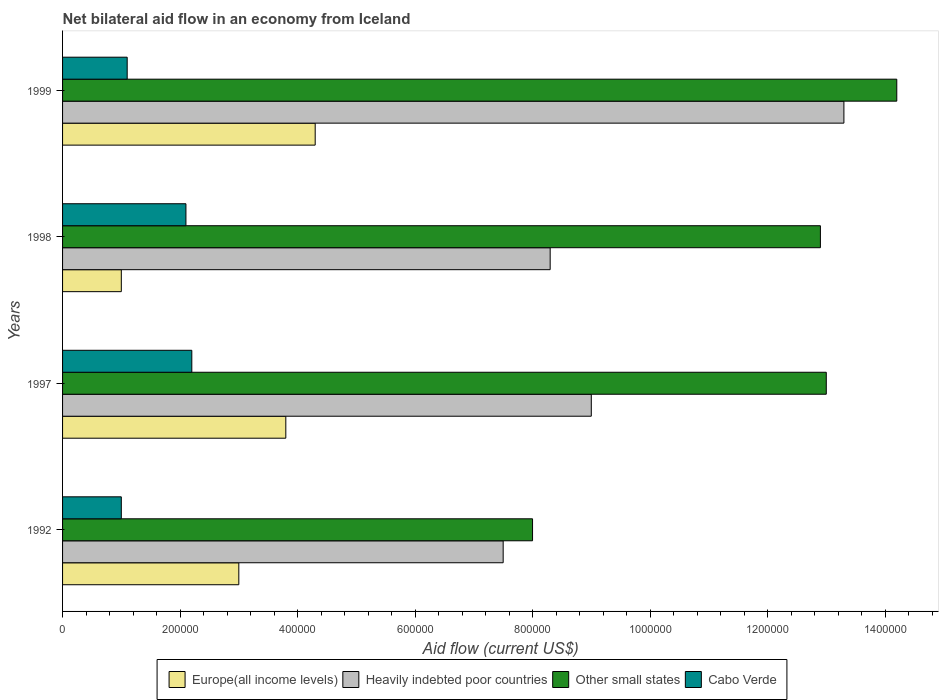How many different coloured bars are there?
Provide a succinct answer. 4. How many groups of bars are there?
Ensure brevity in your answer.  4. Are the number of bars per tick equal to the number of legend labels?
Ensure brevity in your answer.  Yes. Are the number of bars on each tick of the Y-axis equal?
Offer a terse response. Yes. How many bars are there on the 4th tick from the top?
Your response must be concise. 4. What is the net bilateral aid flow in Heavily indebted poor countries in 1999?
Give a very brief answer. 1.33e+06. Across all years, what is the maximum net bilateral aid flow in Heavily indebted poor countries?
Make the answer very short. 1.33e+06. Across all years, what is the minimum net bilateral aid flow in Other small states?
Ensure brevity in your answer.  8.00e+05. What is the total net bilateral aid flow in Europe(all income levels) in the graph?
Give a very brief answer. 1.21e+06. What is the difference between the net bilateral aid flow in Europe(all income levels) in 1997 and the net bilateral aid flow in Cabo Verde in 1999?
Your response must be concise. 2.70e+05. What is the average net bilateral aid flow in Europe(all income levels) per year?
Your answer should be compact. 3.02e+05. In the year 1997, what is the difference between the net bilateral aid flow in Cabo Verde and net bilateral aid flow in Other small states?
Your answer should be very brief. -1.08e+06. What is the ratio of the net bilateral aid flow in Other small states in 1992 to that in 1997?
Keep it short and to the point. 0.62. Is the net bilateral aid flow in Cabo Verde in 1992 less than that in 1999?
Provide a short and direct response. Yes. Is the difference between the net bilateral aid flow in Cabo Verde in 1997 and 1998 greater than the difference between the net bilateral aid flow in Other small states in 1997 and 1998?
Your response must be concise. No. What is the difference between the highest and the second highest net bilateral aid flow in Europe(all income levels)?
Provide a succinct answer. 5.00e+04. What is the difference between the highest and the lowest net bilateral aid flow in Heavily indebted poor countries?
Keep it short and to the point. 5.80e+05. In how many years, is the net bilateral aid flow in Other small states greater than the average net bilateral aid flow in Other small states taken over all years?
Ensure brevity in your answer.  3. Is it the case that in every year, the sum of the net bilateral aid flow in Heavily indebted poor countries and net bilateral aid flow in Cabo Verde is greater than the sum of net bilateral aid flow in Other small states and net bilateral aid flow in Europe(all income levels)?
Your answer should be compact. No. What does the 2nd bar from the top in 1998 represents?
Keep it short and to the point. Other small states. What does the 2nd bar from the bottom in 1998 represents?
Offer a terse response. Heavily indebted poor countries. Is it the case that in every year, the sum of the net bilateral aid flow in Europe(all income levels) and net bilateral aid flow in Cabo Verde is greater than the net bilateral aid flow in Other small states?
Make the answer very short. No. Are all the bars in the graph horizontal?
Your answer should be very brief. Yes. What is the difference between two consecutive major ticks on the X-axis?
Make the answer very short. 2.00e+05. Are the values on the major ticks of X-axis written in scientific E-notation?
Give a very brief answer. No. Does the graph contain any zero values?
Your answer should be very brief. No. How are the legend labels stacked?
Make the answer very short. Horizontal. What is the title of the graph?
Offer a terse response. Net bilateral aid flow in an economy from Iceland. What is the label or title of the X-axis?
Your response must be concise. Aid flow (current US$). What is the Aid flow (current US$) in Europe(all income levels) in 1992?
Offer a very short reply. 3.00e+05. What is the Aid flow (current US$) of Heavily indebted poor countries in 1992?
Your response must be concise. 7.50e+05. What is the Aid flow (current US$) of Cabo Verde in 1992?
Your response must be concise. 1.00e+05. What is the Aid flow (current US$) in Heavily indebted poor countries in 1997?
Keep it short and to the point. 9.00e+05. What is the Aid flow (current US$) in Other small states in 1997?
Offer a very short reply. 1.30e+06. What is the Aid flow (current US$) of Heavily indebted poor countries in 1998?
Make the answer very short. 8.30e+05. What is the Aid flow (current US$) in Other small states in 1998?
Keep it short and to the point. 1.29e+06. What is the Aid flow (current US$) of Heavily indebted poor countries in 1999?
Give a very brief answer. 1.33e+06. What is the Aid flow (current US$) in Other small states in 1999?
Provide a succinct answer. 1.42e+06. What is the Aid flow (current US$) in Cabo Verde in 1999?
Provide a short and direct response. 1.10e+05. Across all years, what is the maximum Aid flow (current US$) in Heavily indebted poor countries?
Provide a succinct answer. 1.33e+06. Across all years, what is the maximum Aid flow (current US$) of Other small states?
Keep it short and to the point. 1.42e+06. Across all years, what is the maximum Aid flow (current US$) in Cabo Verde?
Your answer should be very brief. 2.20e+05. Across all years, what is the minimum Aid flow (current US$) of Heavily indebted poor countries?
Offer a terse response. 7.50e+05. Across all years, what is the minimum Aid flow (current US$) in Cabo Verde?
Your answer should be very brief. 1.00e+05. What is the total Aid flow (current US$) in Europe(all income levels) in the graph?
Your answer should be compact. 1.21e+06. What is the total Aid flow (current US$) in Heavily indebted poor countries in the graph?
Provide a short and direct response. 3.81e+06. What is the total Aid flow (current US$) of Other small states in the graph?
Provide a short and direct response. 4.81e+06. What is the total Aid flow (current US$) in Cabo Verde in the graph?
Give a very brief answer. 6.40e+05. What is the difference between the Aid flow (current US$) in Europe(all income levels) in 1992 and that in 1997?
Provide a succinct answer. -8.00e+04. What is the difference between the Aid flow (current US$) in Heavily indebted poor countries in 1992 and that in 1997?
Offer a terse response. -1.50e+05. What is the difference between the Aid flow (current US$) in Other small states in 1992 and that in 1997?
Your answer should be compact. -5.00e+05. What is the difference between the Aid flow (current US$) of Cabo Verde in 1992 and that in 1997?
Ensure brevity in your answer.  -1.20e+05. What is the difference between the Aid flow (current US$) in Europe(all income levels) in 1992 and that in 1998?
Give a very brief answer. 2.00e+05. What is the difference between the Aid flow (current US$) in Heavily indebted poor countries in 1992 and that in 1998?
Your response must be concise. -8.00e+04. What is the difference between the Aid flow (current US$) in Other small states in 1992 and that in 1998?
Your response must be concise. -4.90e+05. What is the difference between the Aid flow (current US$) of Cabo Verde in 1992 and that in 1998?
Your answer should be compact. -1.10e+05. What is the difference between the Aid flow (current US$) of Heavily indebted poor countries in 1992 and that in 1999?
Keep it short and to the point. -5.80e+05. What is the difference between the Aid flow (current US$) in Other small states in 1992 and that in 1999?
Provide a succinct answer. -6.20e+05. What is the difference between the Aid flow (current US$) of Cabo Verde in 1992 and that in 1999?
Provide a short and direct response. -10000. What is the difference between the Aid flow (current US$) in Cabo Verde in 1997 and that in 1998?
Keep it short and to the point. 10000. What is the difference between the Aid flow (current US$) in Europe(all income levels) in 1997 and that in 1999?
Your answer should be very brief. -5.00e+04. What is the difference between the Aid flow (current US$) of Heavily indebted poor countries in 1997 and that in 1999?
Your answer should be compact. -4.30e+05. What is the difference between the Aid flow (current US$) in Other small states in 1997 and that in 1999?
Provide a short and direct response. -1.20e+05. What is the difference between the Aid flow (current US$) of Cabo Verde in 1997 and that in 1999?
Your answer should be compact. 1.10e+05. What is the difference between the Aid flow (current US$) of Europe(all income levels) in 1998 and that in 1999?
Ensure brevity in your answer.  -3.30e+05. What is the difference between the Aid flow (current US$) of Heavily indebted poor countries in 1998 and that in 1999?
Offer a very short reply. -5.00e+05. What is the difference between the Aid flow (current US$) in Other small states in 1998 and that in 1999?
Offer a very short reply. -1.30e+05. What is the difference between the Aid flow (current US$) in Cabo Verde in 1998 and that in 1999?
Make the answer very short. 1.00e+05. What is the difference between the Aid flow (current US$) in Europe(all income levels) in 1992 and the Aid flow (current US$) in Heavily indebted poor countries in 1997?
Your answer should be very brief. -6.00e+05. What is the difference between the Aid flow (current US$) in Heavily indebted poor countries in 1992 and the Aid flow (current US$) in Other small states in 1997?
Offer a very short reply. -5.50e+05. What is the difference between the Aid flow (current US$) of Heavily indebted poor countries in 1992 and the Aid flow (current US$) of Cabo Verde in 1997?
Provide a succinct answer. 5.30e+05. What is the difference between the Aid flow (current US$) of Other small states in 1992 and the Aid flow (current US$) of Cabo Verde in 1997?
Make the answer very short. 5.80e+05. What is the difference between the Aid flow (current US$) of Europe(all income levels) in 1992 and the Aid flow (current US$) of Heavily indebted poor countries in 1998?
Make the answer very short. -5.30e+05. What is the difference between the Aid flow (current US$) of Europe(all income levels) in 1992 and the Aid flow (current US$) of Other small states in 1998?
Make the answer very short. -9.90e+05. What is the difference between the Aid flow (current US$) of Heavily indebted poor countries in 1992 and the Aid flow (current US$) of Other small states in 1998?
Offer a very short reply. -5.40e+05. What is the difference between the Aid flow (current US$) of Heavily indebted poor countries in 1992 and the Aid flow (current US$) of Cabo Verde in 1998?
Your answer should be compact. 5.40e+05. What is the difference between the Aid flow (current US$) of Other small states in 1992 and the Aid flow (current US$) of Cabo Verde in 1998?
Offer a terse response. 5.90e+05. What is the difference between the Aid flow (current US$) of Europe(all income levels) in 1992 and the Aid flow (current US$) of Heavily indebted poor countries in 1999?
Offer a very short reply. -1.03e+06. What is the difference between the Aid flow (current US$) in Europe(all income levels) in 1992 and the Aid flow (current US$) in Other small states in 1999?
Your answer should be compact. -1.12e+06. What is the difference between the Aid flow (current US$) of Heavily indebted poor countries in 1992 and the Aid flow (current US$) of Other small states in 1999?
Offer a very short reply. -6.70e+05. What is the difference between the Aid flow (current US$) of Heavily indebted poor countries in 1992 and the Aid flow (current US$) of Cabo Verde in 1999?
Your answer should be compact. 6.40e+05. What is the difference between the Aid flow (current US$) of Other small states in 1992 and the Aid flow (current US$) of Cabo Verde in 1999?
Give a very brief answer. 6.90e+05. What is the difference between the Aid flow (current US$) in Europe(all income levels) in 1997 and the Aid flow (current US$) in Heavily indebted poor countries in 1998?
Make the answer very short. -4.50e+05. What is the difference between the Aid flow (current US$) in Europe(all income levels) in 1997 and the Aid flow (current US$) in Other small states in 1998?
Provide a succinct answer. -9.10e+05. What is the difference between the Aid flow (current US$) in Heavily indebted poor countries in 1997 and the Aid flow (current US$) in Other small states in 1998?
Make the answer very short. -3.90e+05. What is the difference between the Aid flow (current US$) of Heavily indebted poor countries in 1997 and the Aid flow (current US$) of Cabo Verde in 1998?
Offer a terse response. 6.90e+05. What is the difference between the Aid flow (current US$) of Other small states in 1997 and the Aid flow (current US$) of Cabo Verde in 1998?
Your answer should be compact. 1.09e+06. What is the difference between the Aid flow (current US$) of Europe(all income levels) in 1997 and the Aid flow (current US$) of Heavily indebted poor countries in 1999?
Provide a succinct answer. -9.50e+05. What is the difference between the Aid flow (current US$) in Europe(all income levels) in 1997 and the Aid flow (current US$) in Other small states in 1999?
Your answer should be compact. -1.04e+06. What is the difference between the Aid flow (current US$) in Heavily indebted poor countries in 1997 and the Aid flow (current US$) in Other small states in 1999?
Provide a short and direct response. -5.20e+05. What is the difference between the Aid flow (current US$) of Heavily indebted poor countries in 1997 and the Aid flow (current US$) of Cabo Verde in 1999?
Give a very brief answer. 7.90e+05. What is the difference between the Aid flow (current US$) in Other small states in 1997 and the Aid flow (current US$) in Cabo Verde in 1999?
Offer a terse response. 1.19e+06. What is the difference between the Aid flow (current US$) in Europe(all income levels) in 1998 and the Aid flow (current US$) in Heavily indebted poor countries in 1999?
Make the answer very short. -1.23e+06. What is the difference between the Aid flow (current US$) in Europe(all income levels) in 1998 and the Aid flow (current US$) in Other small states in 1999?
Make the answer very short. -1.32e+06. What is the difference between the Aid flow (current US$) of Heavily indebted poor countries in 1998 and the Aid flow (current US$) of Other small states in 1999?
Your answer should be very brief. -5.90e+05. What is the difference between the Aid flow (current US$) in Heavily indebted poor countries in 1998 and the Aid flow (current US$) in Cabo Verde in 1999?
Keep it short and to the point. 7.20e+05. What is the difference between the Aid flow (current US$) of Other small states in 1998 and the Aid flow (current US$) of Cabo Verde in 1999?
Your response must be concise. 1.18e+06. What is the average Aid flow (current US$) in Europe(all income levels) per year?
Ensure brevity in your answer.  3.02e+05. What is the average Aid flow (current US$) of Heavily indebted poor countries per year?
Your answer should be very brief. 9.52e+05. What is the average Aid flow (current US$) of Other small states per year?
Provide a succinct answer. 1.20e+06. In the year 1992, what is the difference between the Aid flow (current US$) in Europe(all income levels) and Aid flow (current US$) in Heavily indebted poor countries?
Offer a terse response. -4.50e+05. In the year 1992, what is the difference between the Aid flow (current US$) in Europe(all income levels) and Aid flow (current US$) in Other small states?
Keep it short and to the point. -5.00e+05. In the year 1992, what is the difference between the Aid flow (current US$) in Europe(all income levels) and Aid flow (current US$) in Cabo Verde?
Keep it short and to the point. 2.00e+05. In the year 1992, what is the difference between the Aid flow (current US$) of Heavily indebted poor countries and Aid flow (current US$) of Other small states?
Your response must be concise. -5.00e+04. In the year 1992, what is the difference between the Aid flow (current US$) of Heavily indebted poor countries and Aid flow (current US$) of Cabo Verde?
Your answer should be very brief. 6.50e+05. In the year 1992, what is the difference between the Aid flow (current US$) of Other small states and Aid flow (current US$) of Cabo Verde?
Your answer should be compact. 7.00e+05. In the year 1997, what is the difference between the Aid flow (current US$) of Europe(all income levels) and Aid flow (current US$) of Heavily indebted poor countries?
Provide a short and direct response. -5.20e+05. In the year 1997, what is the difference between the Aid flow (current US$) in Europe(all income levels) and Aid flow (current US$) in Other small states?
Your answer should be very brief. -9.20e+05. In the year 1997, what is the difference between the Aid flow (current US$) of Europe(all income levels) and Aid flow (current US$) of Cabo Verde?
Your answer should be compact. 1.60e+05. In the year 1997, what is the difference between the Aid flow (current US$) in Heavily indebted poor countries and Aid flow (current US$) in Other small states?
Provide a short and direct response. -4.00e+05. In the year 1997, what is the difference between the Aid flow (current US$) in Heavily indebted poor countries and Aid flow (current US$) in Cabo Verde?
Provide a succinct answer. 6.80e+05. In the year 1997, what is the difference between the Aid flow (current US$) in Other small states and Aid flow (current US$) in Cabo Verde?
Your answer should be very brief. 1.08e+06. In the year 1998, what is the difference between the Aid flow (current US$) in Europe(all income levels) and Aid flow (current US$) in Heavily indebted poor countries?
Make the answer very short. -7.30e+05. In the year 1998, what is the difference between the Aid flow (current US$) in Europe(all income levels) and Aid flow (current US$) in Other small states?
Your response must be concise. -1.19e+06. In the year 1998, what is the difference between the Aid flow (current US$) of Heavily indebted poor countries and Aid flow (current US$) of Other small states?
Your answer should be compact. -4.60e+05. In the year 1998, what is the difference between the Aid flow (current US$) in Heavily indebted poor countries and Aid flow (current US$) in Cabo Verde?
Your answer should be very brief. 6.20e+05. In the year 1998, what is the difference between the Aid flow (current US$) in Other small states and Aid flow (current US$) in Cabo Verde?
Give a very brief answer. 1.08e+06. In the year 1999, what is the difference between the Aid flow (current US$) in Europe(all income levels) and Aid flow (current US$) in Heavily indebted poor countries?
Give a very brief answer. -9.00e+05. In the year 1999, what is the difference between the Aid flow (current US$) in Europe(all income levels) and Aid flow (current US$) in Other small states?
Give a very brief answer. -9.90e+05. In the year 1999, what is the difference between the Aid flow (current US$) of Europe(all income levels) and Aid flow (current US$) of Cabo Verde?
Ensure brevity in your answer.  3.20e+05. In the year 1999, what is the difference between the Aid flow (current US$) in Heavily indebted poor countries and Aid flow (current US$) in Cabo Verde?
Your response must be concise. 1.22e+06. In the year 1999, what is the difference between the Aid flow (current US$) in Other small states and Aid flow (current US$) in Cabo Verde?
Your answer should be very brief. 1.31e+06. What is the ratio of the Aid flow (current US$) in Europe(all income levels) in 1992 to that in 1997?
Provide a short and direct response. 0.79. What is the ratio of the Aid flow (current US$) in Heavily indebted poor countries in 1992 to that in 1997?
Make the answer very short. 0.83. What is the ratio of the Aid flow (current US$) of Other small states in 1992 to that in 1997?
Your answer should be compact. 0.62. What is the ratio of the Aid flow (current US$) of Cabo Verde in 1992 to that in 1997?
Keep it short and to the point. 0.45. What is the ratio of the Aid flow (current US$) in Europe(all income levels) in 1992 to that in 1998?
Offer a very short reply. 3. What is the ratio of the Aid flow (current US$) in Heavily indebted poor countries in 1992 to that in 1998?
Make the answer very short. 0.9. What is the ratio of the Aid flow (current US$) of Other small states in 1992 to that in 1998?
Your answer should be compact. 0.62. What is the ratio of the Aid flow (current US$) of Cabo Verde in 1992 to that in 1998?
Your response must be concise. 0.48. What is the ratio of the Aid flow (current US$) in Europe(all income levels) in 1992 to that in 1999?
Give a very brief answer. 0.7. What is the ratio of the Aid flow (current US$) of Heavily indebted poor countries in 1992 to that in 1999?
Make the answer very short. 0.56. What is the ratio of the Aid flow (current US$) in Other small states in 1992 to that in 1999?
Offer a very short reply. 0.56. What is the ratio of the Aid flow (current US$) of Heavily indebted poor countries in 1997 to that in 1998?
Ensure brevity in your answer.  1.08. What is the ratio of the Aid flow (current US$) of Other small states in 1997 to that in 1998?
Ensure brevity in your answer.  1.01. What is the ratio of the Aid flow (current US$) in Cabo Verde in 1997 to that in 1998?
Make the answer very short. 1.05. What is the ratio of the Aid flow (current US$) of Europe(all income levels) in 1997 to that in 1999?
Provide a short and direct response. 0.88. What is the ratio of the Aid flow (current US$) in Heavily indebted poor countries in 1997 to that in 1999?
Your answer should be very brief. 0.68. What is the ratio of the Aid flow (current US$) in Other small states in 1997 to that in 1999?
Make the answer very short. 0.92. What is the ratio of the Aid flow (current US$) of Europe(all income levels) in 1998 to that in 1999?
Your answer should be compact. 0.23. What is the ratio of the Aid flow (current US$) of Heavily indebted poor countries in 1998 to that in 1999?
Your answer should be very brief. 0.62. What is the ratio of the Aid flow (current US$) of Other small states in 1998 to that in 1999?
Offer a terse response. 0.91. What is the ratio of the Aid flow (current US$) in Cabo Verde in 1998 to that in 1999?
Ensure brevity in your answer.  1.91. What is the difference between the highest and the second highest Aid flow (current US$) in Europe(all income levels)?
Give a very brief answer. 5.00e+04. What is the difference between the highest and the second highest Aid flow (current US$) of Heavily indebted poor countries?
Provide a short and direct response. 4.30e+05. What is the difference between the highest and the second highest Aid flow (current US$) in Other small states?
Your answer should be very brief. 1.20e+05. What is the difference between the highest and the second highest Aid flow (current US$) of Cabo Verde?
Keep it short and to the point. 10000. What is the difference between the highest and the lowest Aid flow (current US$) of Heavily indebted poor countries?
Your answer should be very brief. 5.80e+05. What is the difference between the highest and the lowest Aid flow (current US$) in Other small states?
Ensure brevity in your answer.  6.20e+05. 